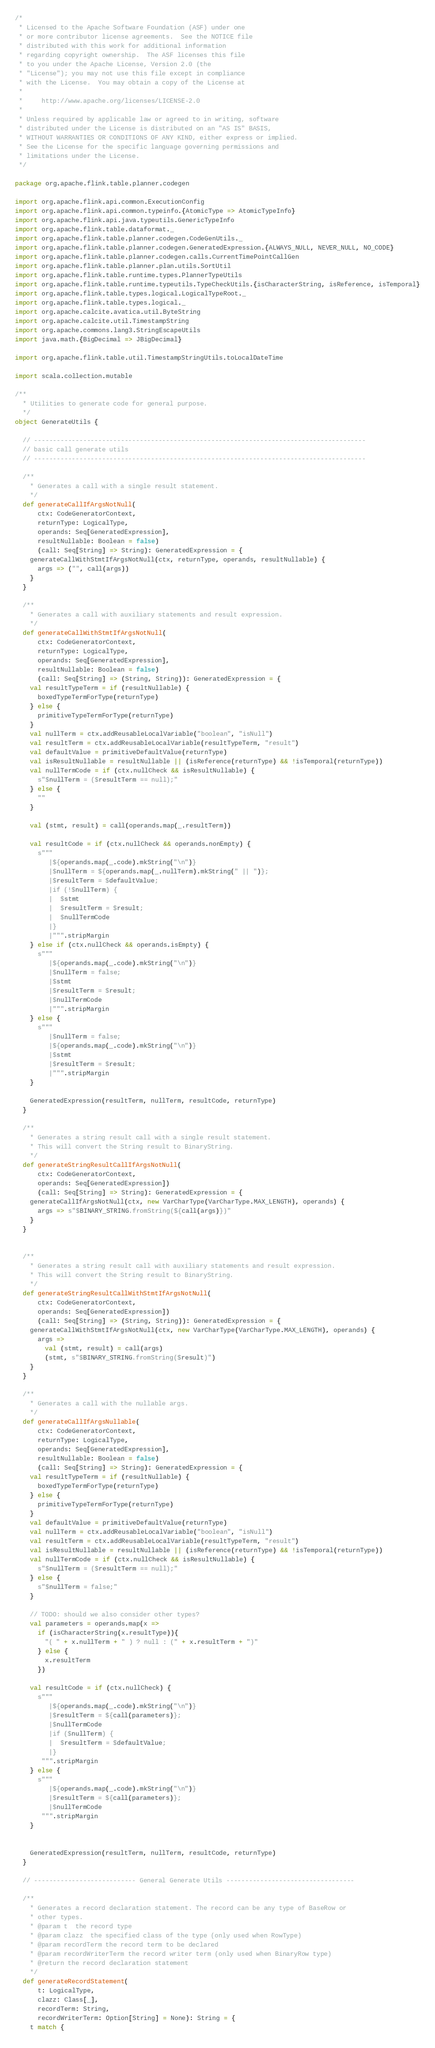Convert code to text. <code><loc_0><loc_0><loc_500><loc_500><_Scala_>/*
 * Licensed to the Apache Software Foundation (ASF) under one
 * or more contributor license agreements.  See the NOTICE file
 * distributed with this work for additional information
 * regarding copyright ownership.  The ASF licenses this file
 * to you under the Apache License, Version 2.0 (the
 * "License"); you may not use this file except in compliance
 * with the License.  You may obtain a copy of the License at
 *
 *     http://www.apache.org/licenses/LICENSE-2.0
 *
 * Unless required by applicable law or agreed to in writing, software
 * distributed under the License is distributed on an "AS IS" BASIS,
 * WITHOUT WARRANTIES OR CONDITIONS OF ANY KIND, either express or implied.
 * See the License for the specific language governing permissions and
 * limitations under the License.
 */

package org.apache.flink.table.planner.codegen

import org.apache.flink.api.common.ExecutionConfig
import org.apache.flink.api.common.typeinfo.{AtomicType => AtomicTypeInfo}
import org.apache.flink.api.java.typeutils.GenericTypeInfo
import org.apache.flink.table.dataformat._
import org.apache.flink.table.planner.codegen.CodeGenUtils._
import org.apache.flink.table.planner.codegen.GeneratedExpression.{ALWAYS_NULL, NEVER_NULL, NO_CODE}
import org.apache.flink.table.planner.codegen.calls.CurrentTimePointCallGen
import org.apache.flink.table.planner.plan.utils.SortUtil
import org.apache.flink.table.runtime.types.PlannerTypeUtils
import org.apache.flink.table.runtime.typeutils.TypeCheckUtils.{isCharacterString, isReference, isTemporal}
import org.apache.flink.table.types.logical.LogicalTypeRoot._
import org.apache.flink.table.types.logical._
import org.apache.calcite.avatica.util.ByteString
import org.apache.calcite.util.TimestampString
import org.apache.commons.lang3.StringEscapeUtils
import java.math.{BigDecimal => JBigDecimal}

import org.apache.flink.table.util.TimestampStringUtils.toLocalDateTime

import scala.collection.mutable

/**
  * Utilities to generate code for general purpose.
  */
object GenerateUtils {

  // ----------------------------------------------------------------------------------------
  // basic call generate utils
  // ----------------------------------------------------------------------------------------

  /**
    * Generates a call with a single result statement.
    */
  def generateCallIfArgsNotNull(
      ctx: CodeGeneratorContext,
      returnType: LogicalType,
      operands: Seq[GeneratedExpression],
      resultNullable: Boolean = false)
      (call: Seq[String] => String): GeneratedExpression = {
    generateCallWithStmtIfArgsNotNull(ctx, returnType, operands, resultNullable) {
      args => ("", call(args))
    }
  }

  /**
    * Generates a call with auxiliary statements and result expression.
    */
  def generateCallWithStmtIfArgsNotNull(
      ctx: CodeGeneratorContext,
      returnType: LogicalType,
      operands: Seq[GeneratedExpression],
      resultNullable: Boolean = false)
      (call: Seq[String] => (String, String)): GeneratedExpression = {
    val resultTypeTerm = if (resultNullable) {
      boxedTypeTermForType(returnType)
    } else {
      primitiveTypeTermForType(returnType)
    }
    val nullTerm = ctx.addReusableLocalVariable("boolean", "isNull")
    val resultTerm = ctx.addReusableLocalVariable(resultTypeTerm, "result")
    val defaultValue = primitiveDefaultValue(returnType)
    val isResultNullable = resultNullable || (isReference(returnType) && !isTemporal(returnType))
    val nullTermCode = if (ctx.nullCheck && isResultNullable) {
      s"$nullTerm = ($resultTerm == null);"
    } else {
      ""
    }

    val (stmt, result) = call(operands.map(_.resultTerm))

    val resultCode = if (ctx.nullCheck && operands.nonEmpty) {
      s"""
         |${operands.map(_.code).mkString("\n")}
         |$nullTerm = ${operands.map(_.nullTerm).mkString(" || ")};
         |$resultTerm = $defaultValue;
         |if (!$nullTerm) {
         |  $stmt
         |  $resultTerm = $result;
         |  $nullTermCode
         |}
         |""".stripMargin
    } else if (ctx.nullCheck && operands.isEmpty) {
      s"""
         |${operands.map(_.code).mkString("\n")}
         |$nullTerm = false;
         |$stmt
         |$resultTerm = $result;
         |$nullTermCode
         |""".stripMargin
    } else {
      s"""
         |$nullTerm = false;
         |${operands.map(_.code).mkString("\n")}
         |$stmt
         |$resultTerm = $result;
         |""".stripMargin
    }

    GeneratedExpression(resultTerm, nullTerm, resultCode, returnType)
  }

  /**
    * Generates a string result call with a single result statement.
    * This will convert the String result to BinaryString.
    */
  def generateStringResultCallIfArgsNotNull(
      ctx: CodeGeneratorContext,
      operands: Seq[GeneratedExpression])
      (call: Seq[String] => String): GeneratedExpression = {
    generateCallIfArgsNotNull(ctx, new VarCharType(VarCharType.MAX_LENGTH), operands) {
      args => s"$BINARY_STRING.fromString(${call(args)})"
    }
  }


  /**
    * Generates a string result call with auxiliary statements and result expression.
    * This will convert the String result to BinaryString.
    */
  def generateStringResultCallWithStmtIfArgsNotNull(
      ctx: CodeGeneratorContext,
      operands: Seq[GeneratedExpression])
      (call: Seq[String] => (String, String)): GeneratedExpression = {
    generateCallWithStmtIfArgsNotNull(ctx, new VarCharType(VarCharType.MAX_LENGTH), operands) {
      args =>
        val (stmt, result) = call(args)
        (stmt, s"$BINARY_STRING.fromString($result)")
    }
  }

  /**
    * Generates a call with the nullable args.
    */
  def generateCallIfArgsNullable(
      ctx: CodeGeneratorContext,
      returnType: LogicalType,
      operands: Seq[GeneratedExpression],
      resultNullable: Boolean = false)
      (call: Seq[String] => String): GeneratedExpression = {
    val resultTypeTerm = if (resultNullable) {
      boxedTypeTermForType(returnType)
    } else {
      primitiveTypeTermForType(returnType)
    }
    val defaultValue = primitiveDefaultValue(returnType)
    val nullTerm = ctx.addReusableLocalVariable("boolean", "isNull")
    val resultTerm = ctx.addReusableLocalVariable(resultTypeTerm, "result")
    val isResultNullable = resultNullable || (isReference(returnType) && !isTemporal(returnType))
    val nullTermCode = if (ctx.nullCheck && isResultNullable) {
      s"$nullTerm = ($resultTerm == null);"
    } else {
      s"$nullTerm = false;"
    }

    // TODO: should we also consider other types?
    val parameters = operands.map(x =>
      if (isCharacterString(x.resultType)){
        "( " + x.nullTerm + " ) ? null : (" + x.resultTerm + ")"
      } else {
        x.resultTerm
      })

    val resultCode = if (ctx.nullCheck) {
      s"""
         |${operands.map(_.code).mkString("\n")}
         |$resultTerm = ${call(parameters)};
         |$nullTermCode
         |if ($nullTerm) {
         |  $resultTerm = $defaultValue;
         |}
       """.stripMargin
    } else {
      s"""
         |${operands.map(_.code).mkString("\n")}
         |$resultTerm = ${call(parameters)};
         |$nullTermCode
       """.stripMargin
    }


    GeneratedExpression(resultTerm, nullTerm, resultCode, returnType)
  }

  // --------------------------- General Generate Utils ----------------------------------

  /**
    * Generates a record declaration statement. The record can be any type of BaseRow or
    * other types.
    * @param t  the record type
    * @param clazz  the specified class of the type (only used when RowType)
    * @param recordTerm the record term to be declared
    * @param recordWriterTerm the record writer term (only used when BinaryRow type)
    * @return the record declaration statement
    */
  def generateRecordStatement(
      t: LogicalType,
      clazz: Class[_],
      recordTerm: String,
      recordWriterTerm: Option[String] = None): String = {
    t match {</code> 